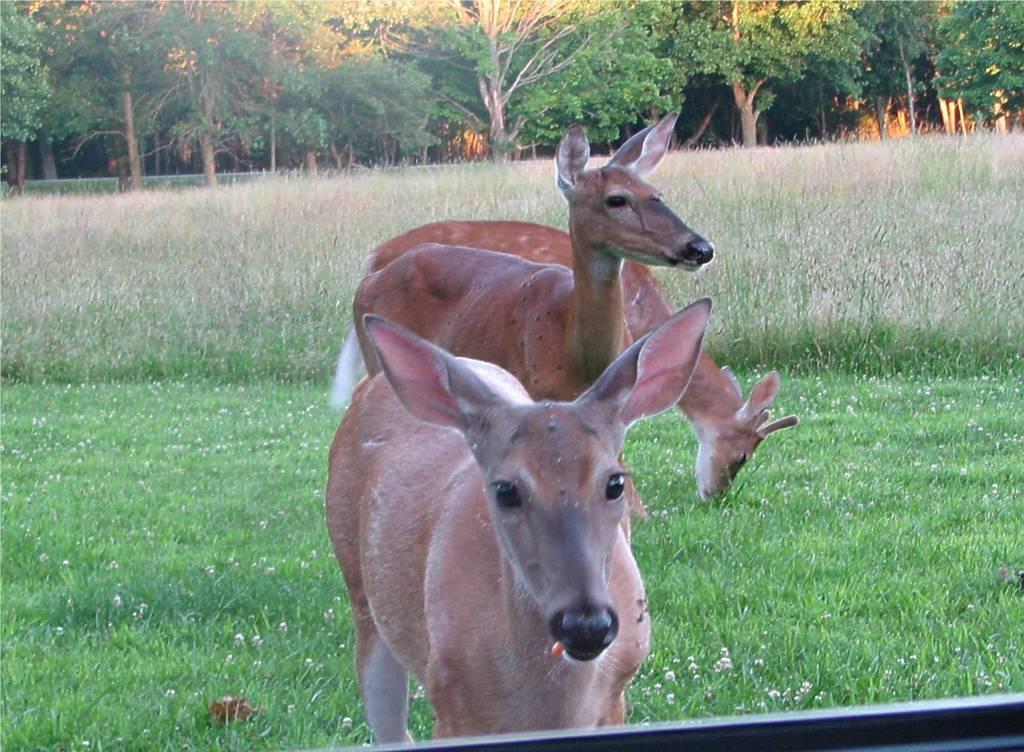Could you give a brief overview of what you see in this image? There are three dress standing. This is the grass. In the background, I can see the trees with branches and leaves. 